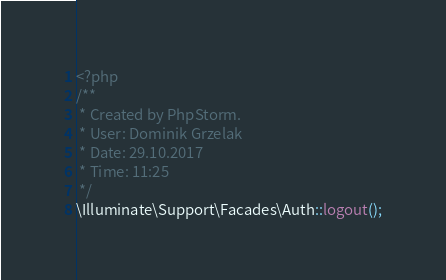Convert code to text. <code><loc_0><loc_0><loc_500><loc_500><_PHP_><?php
/**
 * Created by PhpStorm.
 * User: Dominik Grzelak
 * Date: 29.10.2017
 * Time: 11:25
 */
\Illuminate\Support\Facades\Auth::logout();</code> 